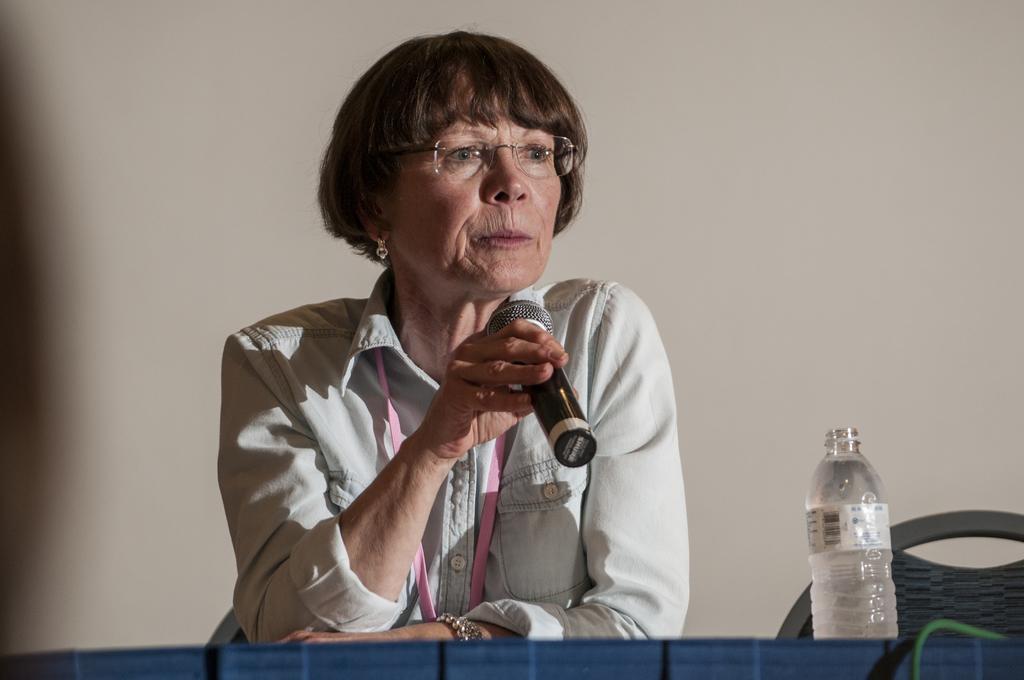How would you summarize this image in a sentence or two? In this image a woman is sitting on a chair and placing her hands on a desk with holding a mic in her hand. At the bottom of the image there is a table and on top of it there is a water bottle with water in it. In the right side on the image there is an empty chair. At the background there is a wall. 